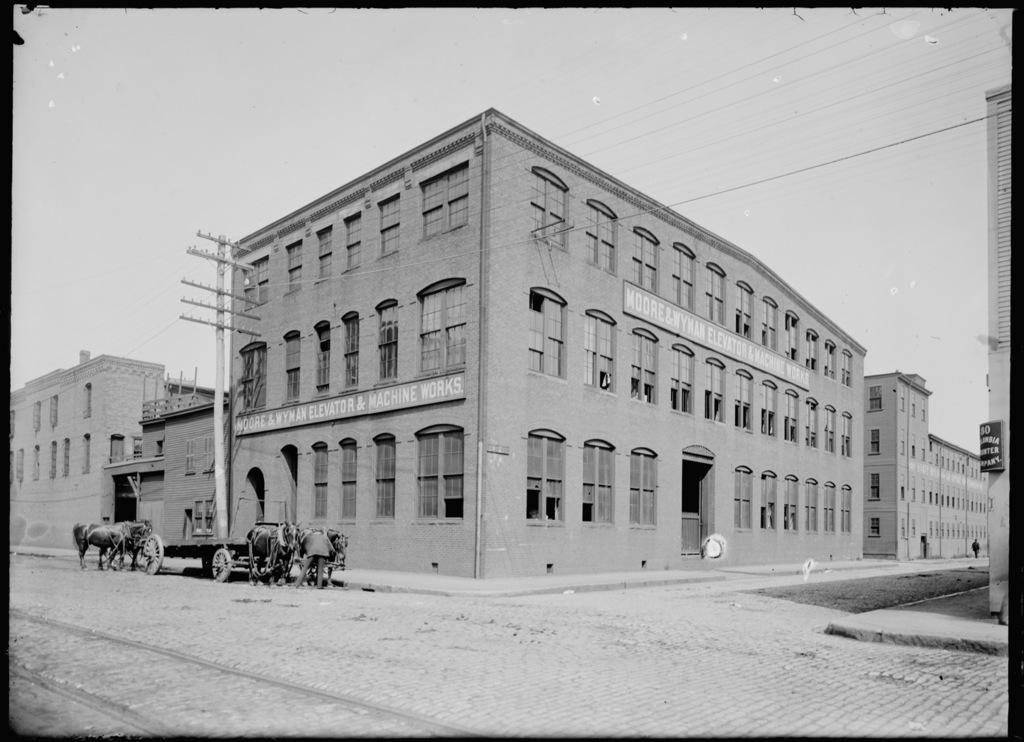In one or two sentences, can you explain what this image depicts? This is a black and white image. We can see a few buildings. We can see a pole and some wires. We can see a cart with some animals. There are a few people. We can see a board with some text. We can see the ground and the sky. 